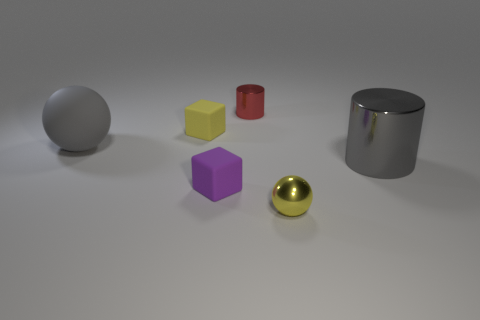Is the shape of the big gray matte object the same as the small red thing?
Your answer should be compact. No. There is a tiny rubber thing that is in front of the cylinder in front of the small rubber object on the left side of the purple object; what is its shape?
Offer a terse response. Cube. Does the large thing in front of the big gray matte sphere have the same shape as the metal thing on the left side of the tiny yellow ball?
Your response must be concise. Yes. Is there a small ball that has the same material as the small red cylinder?
Offer a terse response. Yes. There is a tiny rubber block behind the large gray thing that is to the right of the small cube that is behind the big cylinder; what is its color?
Keep it short and to the point. Yellow. Does the red thing that is to the right of the large gray rubber thing have the same material as the small yellow thing behind the big gray rubber thing?
Keep it short and to the point. No. There is a large gray object that is left of the red metallic cylinder; what shape is it?
Provide a short and direct response. Sphere. What number of things are either red matte cylinders or big objects that are on the right side of the tiny yellow cube?
Your response must be concise. 1. Do the red thing and the yellow sphere have the same material?
Make the answer very short. Yes. Is the number of metallic balls to the left of the tiny red metallic thing the same as the number of matte balls behind the gray matte object?
Make the answer very short. Yes. 